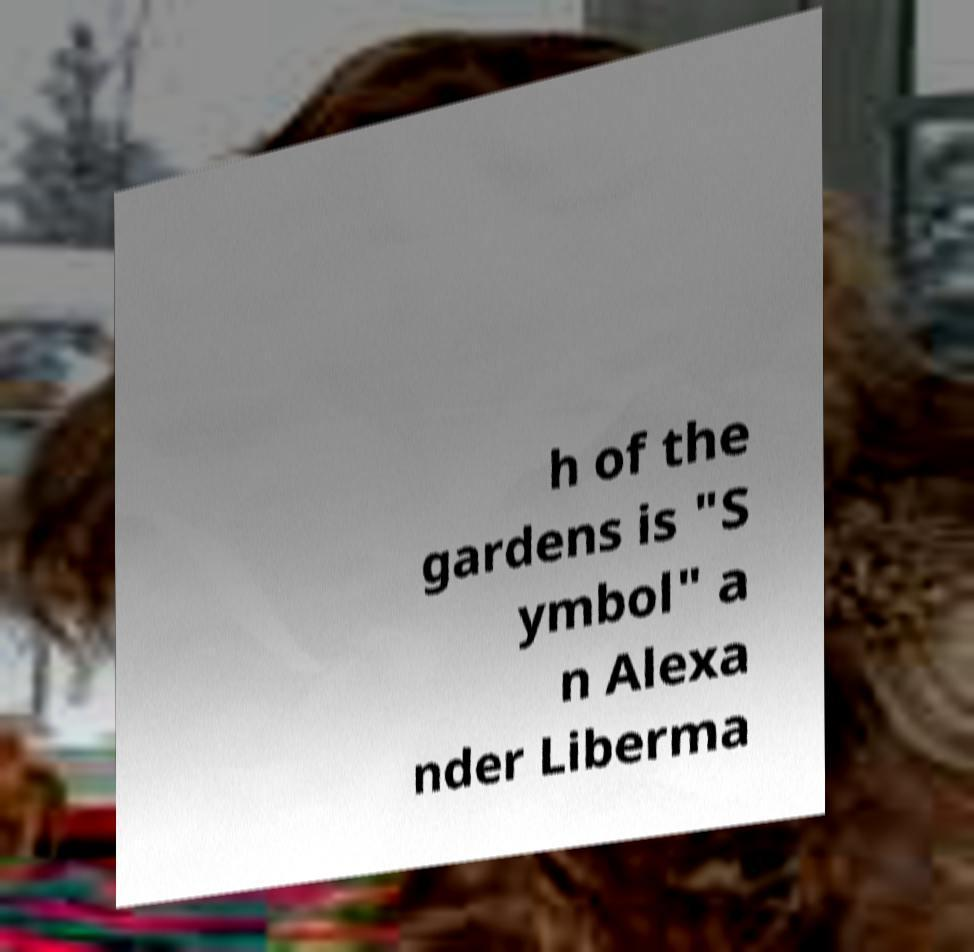Could you assist in decoding the text presented in this image and type it out clearly? h of the gardens is "S ymbol" a n Alexa nder Liberma 